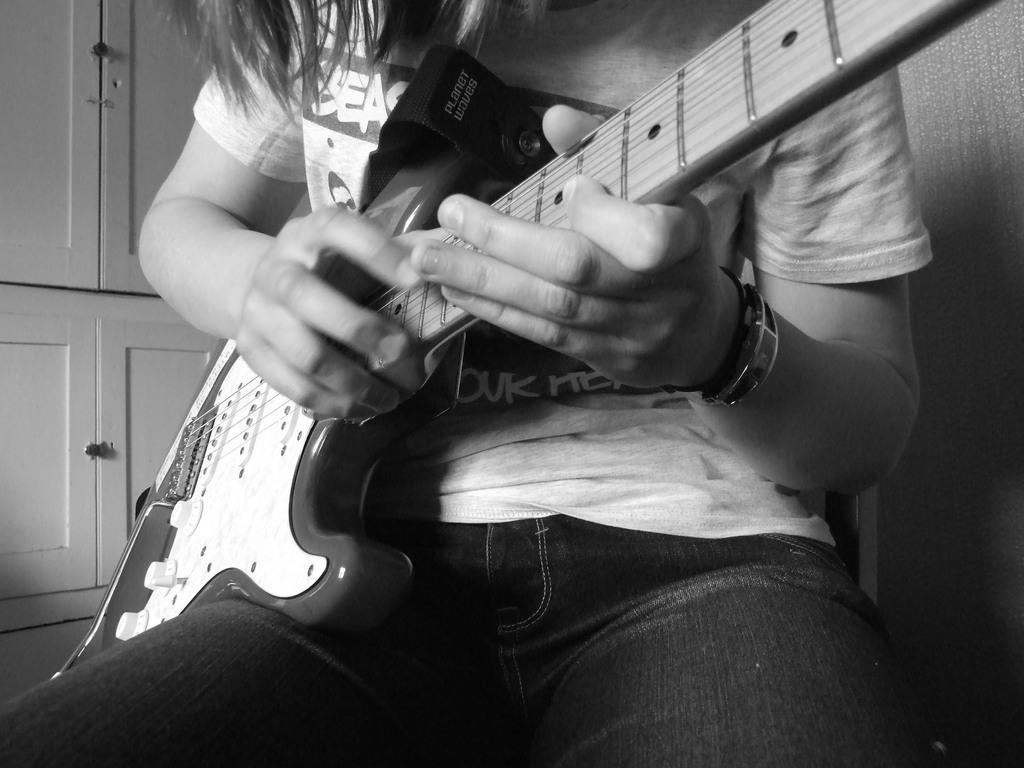Who is present in the image? There is a person in the image. What is the person doing in the image? The person is sitting. What object is the person holding in the image? The person is holding a guitar in his hand. What type of pipe is the person smoking in the image? There is no pipe present in the image; the person is holding a guitar. 